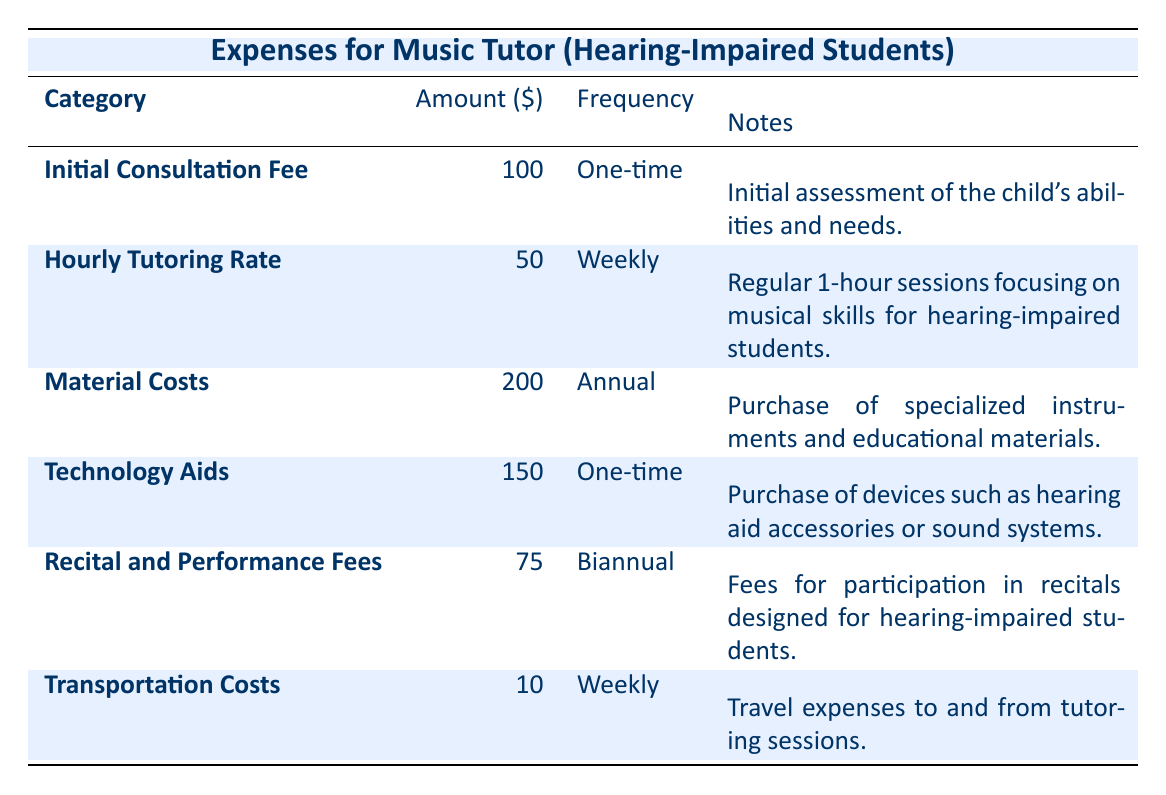What is the Initial Consultation Fee? The table lists the Initial Consultation Fee under the "Category" column, showing that the amount is 100 dollars.
Answer: 100 How often do you pay for the Hourly Tutoring Rate? According to the table, the Hourly Tutoring Rate is listed with a "Frequency" of "Weekly."
Answer: Weekly What is the total cost for Hourly Tutoring over a year? To find out the total cost for Hourly Tutoring, we multiply the weekly amount (50 dollars) by the number of weeks in a year (52), resulting in 50 x 52 = 2600 dollars.
Answer: 2600 Are there any one-time expenses for this music tutoring? The table shows two items (Initial Consultation Fee and Technology Aids) with a "Frequency" of "One-time," indicating there are indeed one-time expenses.
Answer: Yes What are the total annual costs for material and technology aids combined? The Material Costs amount to 200 dollars annually, and the Technology Aids have a one-time cost of 150 dollars. Since one-time costs don't contribute to annual expenses, we only consider the Material Costs, resulting in a total of 200 dollars annually.
Answer: 200 How much is spent on transportation for a month? Transportation Costs are listed as 10 dollars weekly. Over a month (approximately 4 weeks), this would total to 10 x 4 = 40 dollars.
Answer: 40 Is the Recital and Performance Fee a monthly or yearly charge? The table states that the Recital and Performance Fee has a frequency of "Biannual," meaning it's charged twice a year, confirming it's not a monthly or yearly charge.
Answer: No What is the total cost for all music tutoring expenses in the first year including materials? To find the total, we add up the one-time and recurring expenses: Initial Consultation Fee (100) + Hourly Tutoring (2600) + Material Costs (200) + Technology Aids (150) + Recital Fees (75) + Transportation (520, calculated as 10 x 52 for a year). The total is 100 + 2600 + 200 + 150 + 75 + 520 = 3645 dollars.
Answer: 3645 